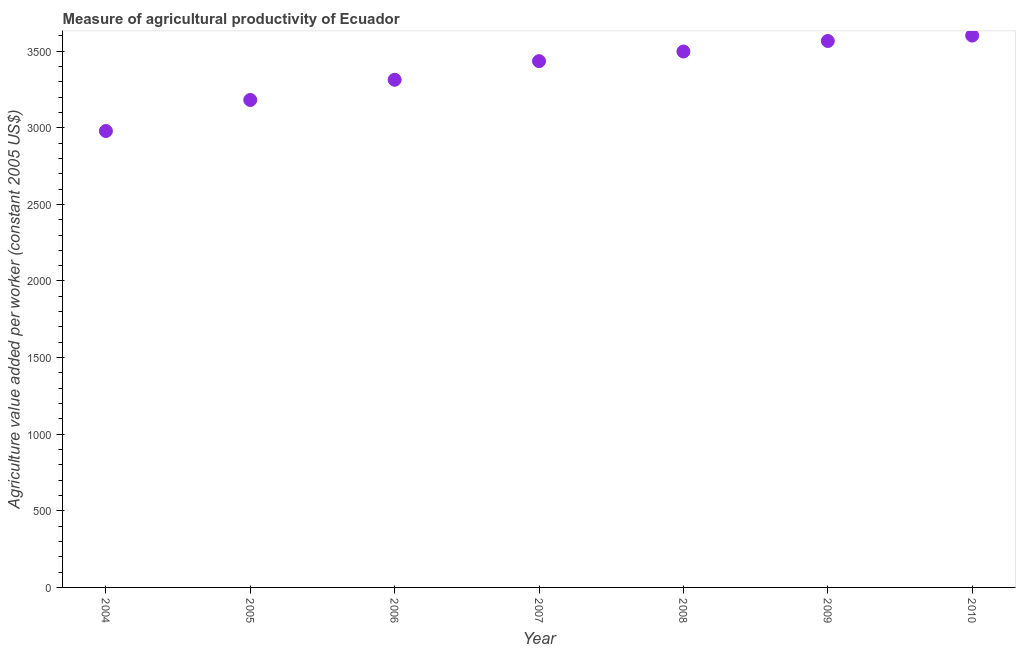What is the agriculture value added per worker in 2008?
Give a very brief answer. 3497.62. Across all years, what is the maximum agriculture value added per worker?
Your answer should be compact. 3601.42. Across all years, what is the minimum agriculture value added per worker?
Offer a terse response. 2978.85. In which year was the agriculture value added per worker minimum?
Your answer should be compact. 2004. What is the sum of the agriculture value added per worker?
Your response must be concise. 2.36e+04. What is the difference between the agriculture value added per worker in 2008 and 2010?
Your answer should be very brief. -103.8. What is the average agriculture value added per worker per year?
Offer a terse response. 3367.62. What is the median agriculture value added per worker?
Provide a succinct answer. 3434.7. In how many years, is the agriculture value added per worker greater than 1000 US$?
Your answer should be very brief. 7. Do a majority of the years between 2007 and 2010 (inclusive) have agriculture value added per worker greater than 1900 US$?
Keep it short and to the point. Yes. What is the ratio of the agriculture value added per worker in 2004 to that in 2010?
Give a very brief answer. 0.83. Is the agriculture value added per worker in 2004 less than that in 2006?
Provide a succinct answer. Yes. Is the difference between the agriculture value added per worker in 2005 and 2009 greater than the difference between any two years?
Your answer should be very brief. No. What is the difference between the highest and the second highest agriculture value added per worker?
Provide a short and direct response. 35.14. Is the sum of the agriculture value added per worker in 2004 and 2010 greater than the maximum agriculture value added per worker across all years?
Offer a terse response. Yes. What is the difference between the highest and the lowest agriculture value added per worker?
Your answer should be very brief. 622.58. Does the agriculture value added per worker monotonically increase over the years?
Keep it short and to the point. Yes. How many years are there in the graph?
Give a very brief answer. 7. What is the difference between two consecutive major ticks on the Y-axis?
Offer a very short reply. 500. Does the graph contain any zero values?
Your response must be concise. No. What is the title of the graph?
Provide a succinct answer. Measure of agricultural productivity of Ecuador. What is the label or title of the X-axis?
Keep it short and to the point. Year. What is the label or title of the Y-axis?
Keep it short and to the point. Agriculture value added per worker (constant 2005 US$). What is the Agriculture value added per worker (constant 2005 US$) in 2004?
Ensure brevity in your answer.  2978.85. What is the Agriculture value added per worker (constant 2005 US$) in 2005?
Give a very brief answer. 3181.37. What is the Agriculture value added per worker (constant 2005 US$) in 2006?
Provide a succinct answer. 3313.09. What is the Agriculture value added per worker (constant 2005 US$) in 2007?
Keep it short and to the point. 3434.7. What is the Agriculture value added per worker (constant 2005 US$) in 2008?
Offer a terse response. 3497.62. What is the Agriculture value added per worker (constant 2005 US$) in 2009?
Offer a very short reply. 3566.28. What is the Agriculture value added per worker (constant 2005 US$) in 2010?
Your response must be concise. 3601.42. What is the difference between the Agriculture value added per worker (constant 2005 US$) in 2004 and 2005?
Give a very brief answer. -202.52. What is the difference between the Agriculture value added per worker (constant 2005 US$) in 2004 and 2006?
Make the answer very short. -334.24. What is the difference between the Agriculture value added per worker (constant 2005 US$) in 2004 and 2007?
Your answer should be compact. -455.85. What is the difference between the Agriculture value added per worker (constant 2005 US$) in 2004 and 2008?
Give a very brief answer. -518.77. What is the difference between the Agriculture value added per worker (constant 2005 US$) in 2004 and 2009?
Give a very brief answer. -587.43. What is the difference between the Agriculture value added per worker (constant 2005 US$) in 2004 and 2010?
Your answer should be compact. -622.58. What is the difference between the Agriculture value added per worker (constant 2005 US$) in 2005 and 2006?
Offer a terse response. -131.72. What is the difference between the Agriculture value added per worker (constant 2005 US$) in 2005 and 2007?
Offer a very short reply. -253.33. What is the difference between the Agriculture value added per worker (constant 2005 US$) in 2005 and 2008?
Provide a short and direct response. -316.25. What is the difference between the Agriculture value added per worker (constant 2005 US$) in 2005 and 2009?
Your answer should be very brief. -384.91. What is the difference between the Agriculture value added per worker (constant 2005 US$) in 2005 and 2010?
Offer a terse response. -420.05. What is the difference between the Agriculture value added per worker (constant 2005 US$) in 2006 and 2007?
Provide a succinct answer. -121.61. What is the difference between the Agriculture value added per worker (constant 2005 US$) in 2006 and 2008?
Offer a very short reply. -184.53. What is the difference between the Agriculture value added per worker (constant 2005 US$) in 2006 and 2009?
Offer a very short reply. -253.19. What is the difference between the Agriculture value added per worker (constant 2005 US$) in 2006 and 2010?
Ensure brevity in your answer.  -288.33. What is the difference between the Agriculture value added per worker (constant 2005 US$) in 2007 and 2008?
Your answer should be compact. -62.92. What is the difference between the Agriculture value added per worker (constant 2005 US$) in 2007 and 2009?
Provide a succinct answer. -131.58. What is the difference between the Agriculture value added per worker (constant 2005 US$) in 2007 and 2010?
Keep it short and to the point. -166.72. What is the difference between the Agriculture value added per worker (constant 2005 US$) in 2008 and 2009?
Ensure brevity in your answer.  -68.66. What is the difference between the Agriculture value added per worker (constant 2005 US$) in 2008 and 2010?
Your answer should be very brief. -103.8. What is the difference between the Agriculture value added per worker (constant 2005 US$) in 2009 and 2010?
Ensure brevity in your answer.  -35.14. What is the ratio of the Agriculture value added per worker (constant 2005 US$) in 2004 to that in 2005?
Ensure brevity in your answer.  0.94. What is the ratio of the Agriculture value added per worker (constant 2005 US$) in 2004 to that in 2006?
Ensure brevity in your answer.  0.9. What is the ratio of the Agriculture value added per worker (constant 2005 US$) in 2004 to that in 2007?
Ensure brevity in your answer.  0.87. What is the ratio of the Agriculture value added per worker (constant 2005 US$) in 2004 to that in 2008?
Offer a very short reply. 0.85. What is the ratio of the Agriculture value added per worker (constant 2005 US$) in 2004 to that in 2009?
Give a very brief answer. 0.83. What is the ratio of the Agriculture value added per worker (constant 2005 US$) in 2004 to that in 2010?
Make the answer very short. 0.83. What is the ratio of the Agriculture value added per worker (constant 2005 US$) in 2005 to that in 2007?
Keep it short and to the point. 0.93. What is the ratio of the Agriculture value added per worker (constant 2005 US$) in 2005 to that in 2008?
Ensure brevity in your answer.  0.91. What is the ratio of the Agriculture value added per worker (constant 2005 US$) in 2005 to that in 2009?
Make the answer very short. 0.89. What is the ratio of the Agriculture value added per worker (constant 2005 US$) in 2005 to that in 2010?
Your response must be concise. 0.88. What is the ratio of the Agriculture value added per worker (constant 2005 US$) in 2006 to that in 2007?
Provide a short and direct response. 0.96. What is the ratio of the Agriculture value added per worker (constant 2005 US$) in 2006 to that in 2008?
Provide a short and direct response. 0.95. What is the ratio of the Agriculture value added per worker (constant 2005 US$) in 2006 to that in 2009?
Provide a short and direct response. 0.93. What is the ratio of the Agriculture value added per worker (constant 2005 US$) in 2007 to that in 2009?
Your response must be concise. 0.96. What is the ratio of the Agriculture value added per worker (constant 2005 US$) in 2007 to that in 2010?
Provide a succinct answer. 0.95. What is the ratio of the Agriculture value added per worker (constant 2005 US$) in 2008 to that in 2010?
Your response must be concise. 0.97. What is the ratio of the Agriculture value added per worker (constant 2005 US$) in 2009 to that in 2010?
Keep it short and to the point. 0.99. 